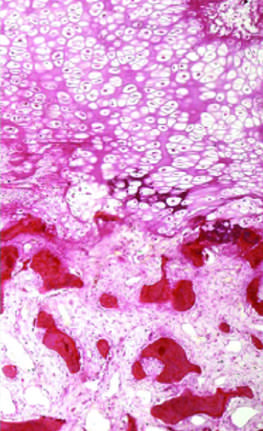re darker trabeculae well-formed bone?
Answer the question using a single word or phrase. Yes 